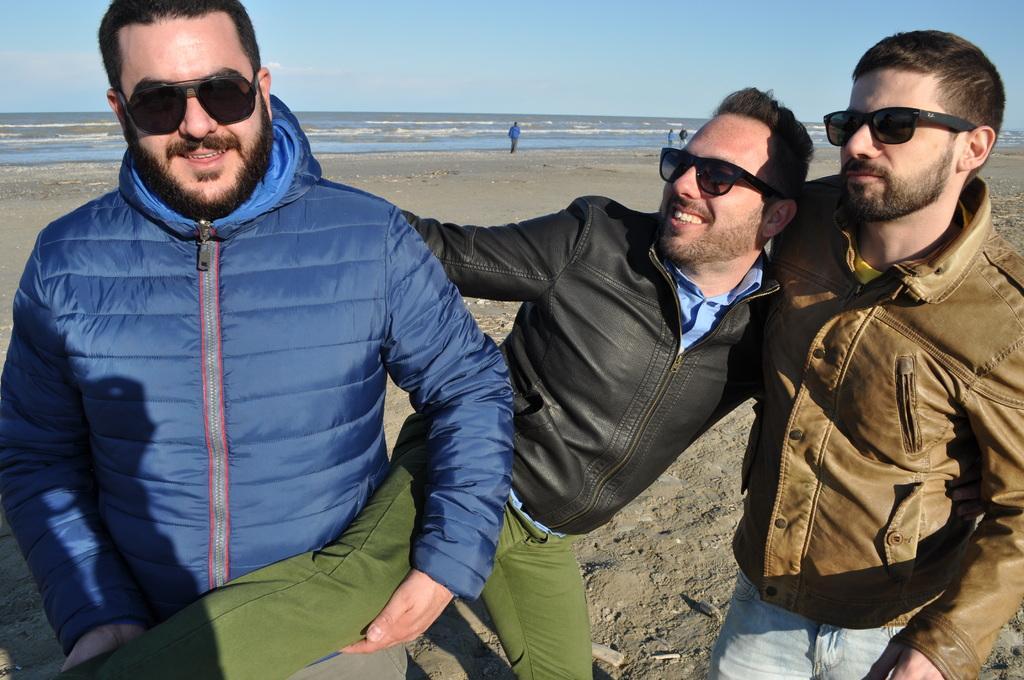In one or two sentences, can you explain what this image depicts? In this image we can see three people standing and posing for a photo and in the background, there are few people and we can see the ocean and at the top we can see the sky. 